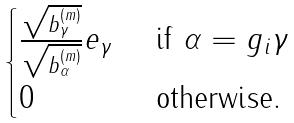Convert formula to latex. <formula><loc_0><loc_0><loc_500><loc_500>\begin{cases} \frac { \sqrt { b _ { \gamma } ^ { ( m ) } } } { \sqrt { b _ { \alpha } ^ { ( m ) } } } e _ { \gamma } & \text { if } \alpha = g _ { i } \gamma \\ 0 & \text { otherwise. } \end{cases}</formula> 